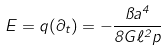Convert formula to latex. <formula><loc_0><loc_0><loc_500><loc_500>E = q ( \partial _ { t } ) = - \frac { \pi a ^ { 4 } } { 8 G \ell ^ { 2 } p }</formula> 